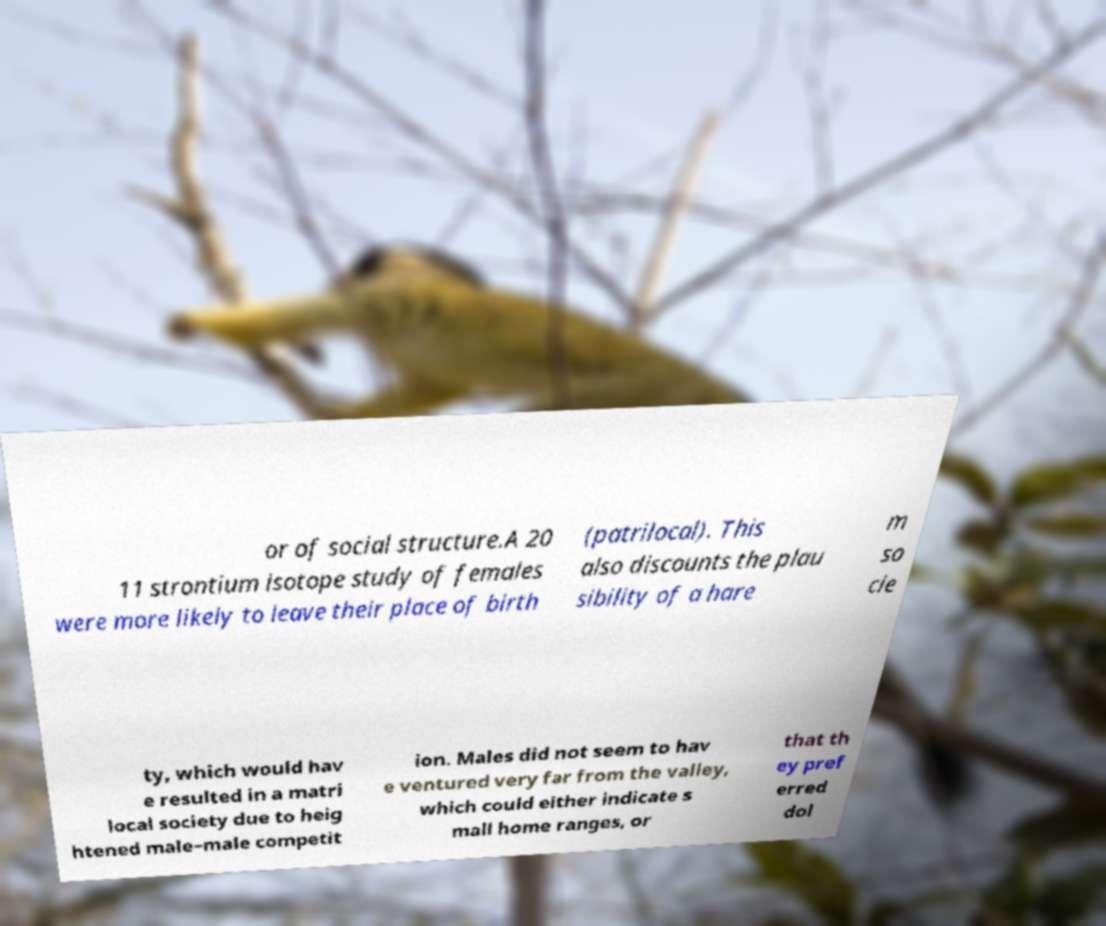Please read and relay the text visible in this image. What does it say? or of social structure.A 20 11 strontium isotope study of females were more likely to leave their place of birth (patrilocal). This also discounts the plau sibility of a hare m so cie ty, which would hav e resulted in a matri local society due to heig htened male–male competit ion. Males did not seem to hav e ventured very far from the valley, which could either indicate s mall home ranges, or that th ey pref erred dol 